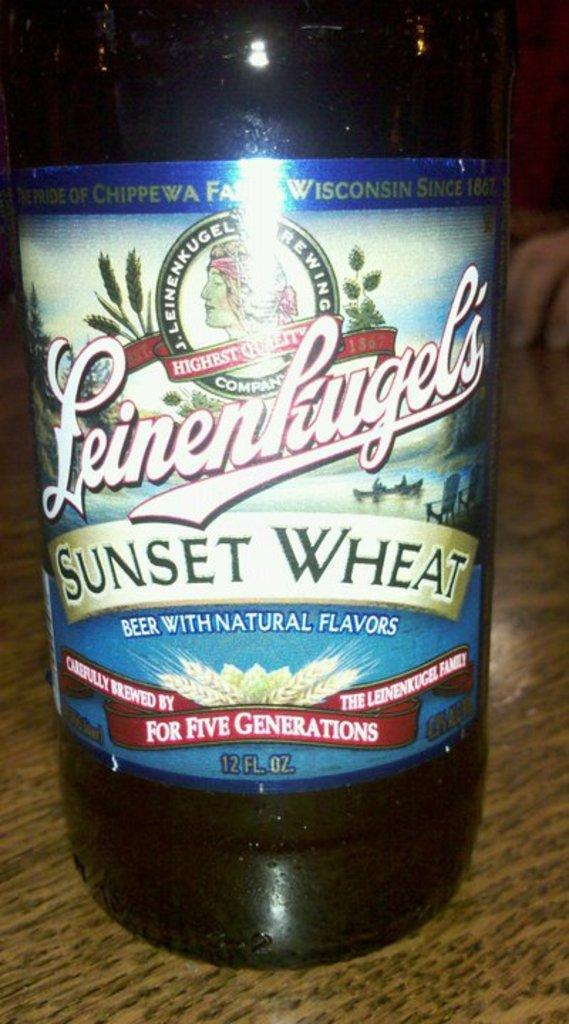What object is placed on the table in the image? There is a bottle on the table. What feature can be observed on the bottle? The bottle has a label. What type of creature can be seen interacting with the bottle in the image? There is no creature present in the image, and therefore no such interaction can be observed. What mark is visible on the label of the bottle in the image? The facts provided do not specify any mark on the label of the bottle, so it cannot be determined from the image. 